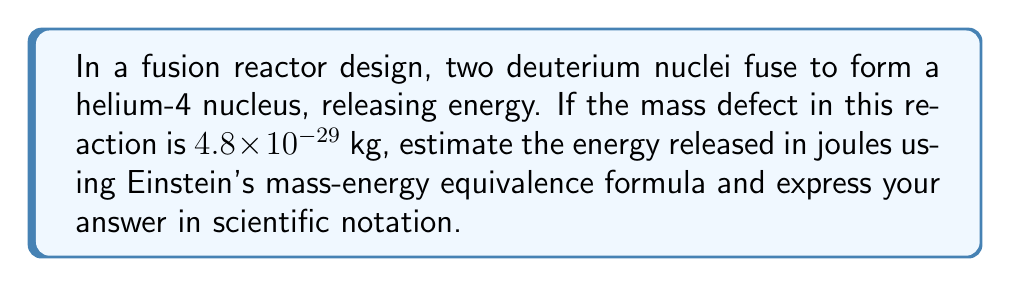Teach me how to tackle this problem. Let's approach this step-by-step:

1) Einstein's mass-energy equivalence formula is:

   $E = mc^2$

   Where:
   $E$ is energy in joules (J)
   $m$ is mass in kilograms (kg)
   $c$ is the speed of light in meters per second (m/s)

2) We're given the mass defect: $m = 4.8 \times 10^{-29}$ kg

3) The speed of light is approximately $c = 3 \times 10^8$ m/s

4) Let's substitute these values into the equation:

   $E = (4.8 \times 10^{-29} \text{ kg}) \times (3 \times 10^8 \text{ m/s})^2$

5) Simplify the exponents:

   $E = 4.8 \times 10^{-29} \times 9 \times 10^{16}$

6) Multiply the coefficients and add the exponents:

   $E = 43.2 \times 10^{-13}$

7) Simplify to standard scientific notation:

   $E = 4.32 \times 10^{-12}$ J

Therefore, the energy released in this fusion reaction is approximately $4.32 \times 10^{-12}$ joules.
Answer: $4.32 \times 10^{-12}$ J 